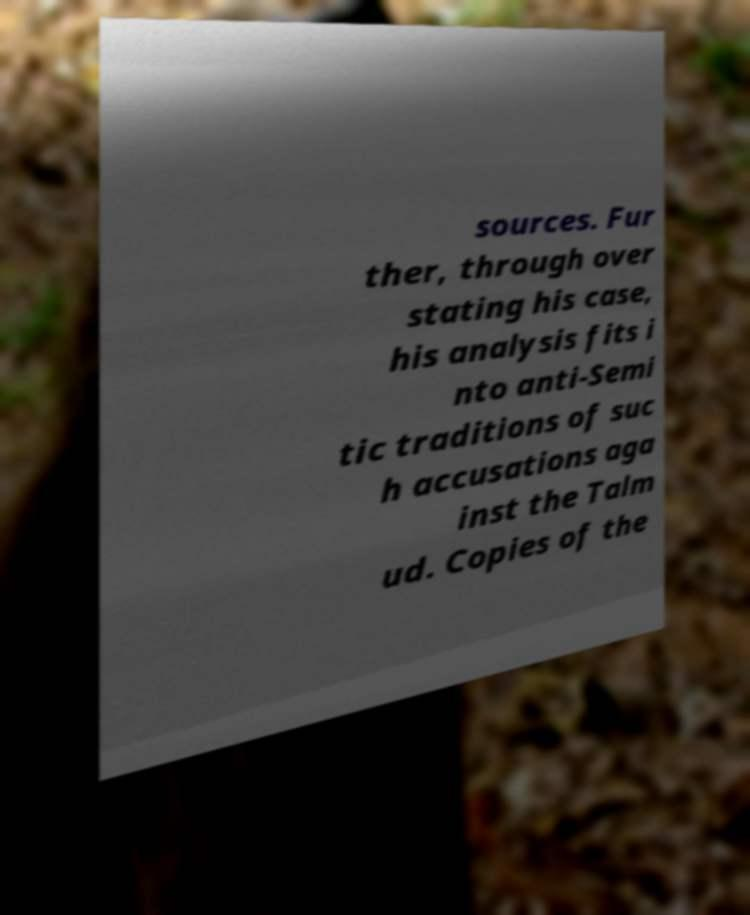Can you read and provide the text displayed in the image?This photo seems to have some interesting text. Can you extract and type it out for me? sources. Fur ther, through over stating his case, his analysis fits i nto anti-Semi tic traditions of suc h accusations aga inst the Talm ud. Copies of the 